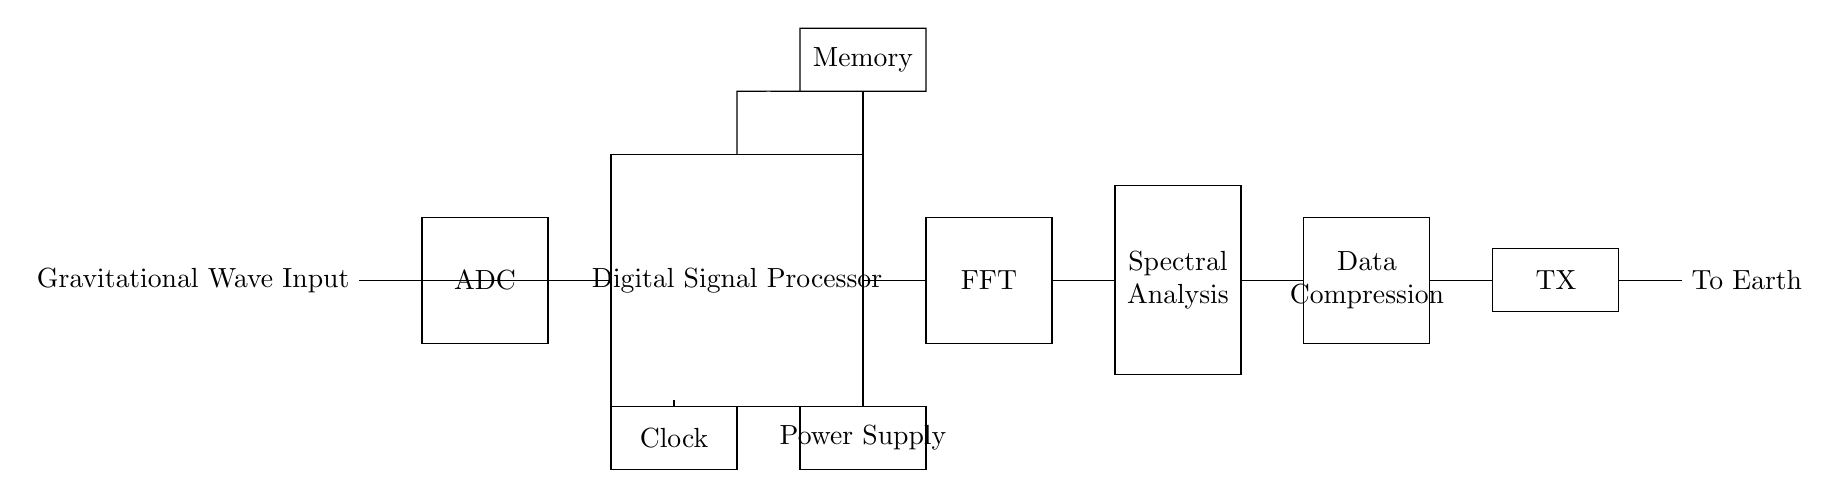What is the main input of this circuit? The main input is "Gravitational Wave Input," which is indicated at the left side of the circuit diagram. This is the signal that the circuit will process.
Answer: Gravitational Wave Input How many major blocks are present in the circuit? The circuit consists of six major blocks: ADC, Digital Signal Processor, Memory, FFT, Spectral Analysis, and Data Compression. These blocks indicate the different functionalities in the signal processing chain.
Answer: Six What component is responsible for converting analog signals to digital signals? The component responsible for this conversion is the ADC (Analog to Digital Converter), which is the first block following the input. Its role is to change an analog gravitational wave signal into a digital format.
Answer: ADC What type of analysis does the circuit perform after the FFT block? After the FFT block, the circuit performs "Spectral Analysis," as indicated in the corresponding block of the diagram. This analysis helps in understanding the frequency components of the gravitational waves.
Answer: Spectral Analysis What is the purpose of the TX block in this circuit? The TX (Transmitter) block's purpose is to send the processed data from the circuit back to Earth. It serves as the output stage after all analyses and data compression is done.
Answer: To send processed data What does the Power Supply block do in this circuit? The Power Supply block provides the necessary electrical energy to power all components in the circuit. Without it, the circuit would not function properly.
Answer: Provides power 